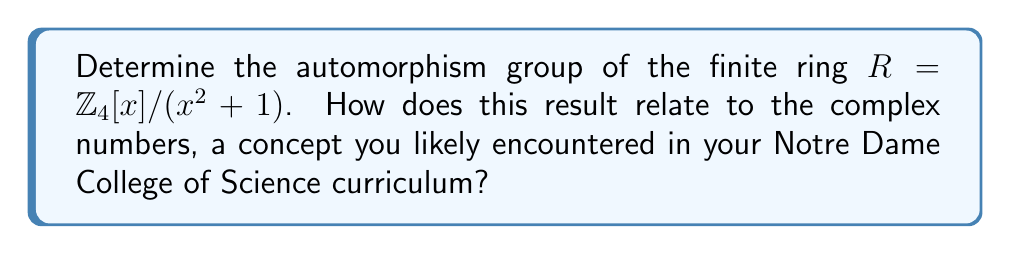Show me your answer to this math problem. Let's approach this step-by-step:

1) First, we need to understand the structure of $R$. It's a quotient ring of $\mathbb{Z}_4[x]$ by the ideal generated by $x^2+1$. This means that in $R$, we have $x^2 \equiv -1 \pmod{4}$.

2) The elements of $R$ can be written as $a + bx$ where $a, b \in \mathbb{Z}_4$. There are 16 elements in total.

3) To find the automorphisms, we need to find ring homomorphisms from $R$ to itself that are bijective. Any such automorphism $\phi$ is completely determined by where it sends $x$, as $\phi(1) = 1$ for any ring homomorphism.

4) For $\phi$ to be a homomorphism, we must have $\phi(x)^2 + 1 = 0$ in $R$. The only elements of $R$ that satisfy this are $x$ and $3x$.

5) Therefore, there are only two possible automorphisms:
   - The identity automorphism: $\phi_1(a + bx) = a + bx$
   - The automorphism that sends $x$ to $3x$: $\phi_2(a + bx) = a + 3bx$

6) We can verify that $\phi_2 \circ \phi_2 = \phi_1$, so the automorphism group is cyclic of order 2.

7) This result is analogous to the automorphism group of the complex numbers $\mathbb{C}$, which consists of the identity and complex conjugation. In fact, $R$ is a "modulo 4" version of the complex numbers, where $x$ plays the role of $i$.
Answer: The automorphism group of $R = \mathbb{Z}_4[x]/(x^2+1)$ is isomorphic to $\mathbb{Z}_2$, the cyclic group of order 2. 